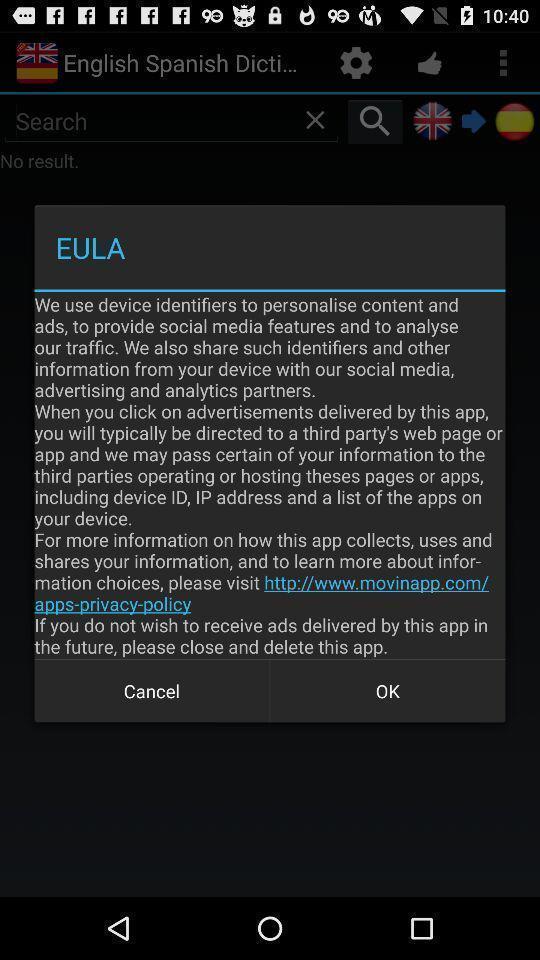What details can you identify in this image? Pop-up message displaying information about the application. 